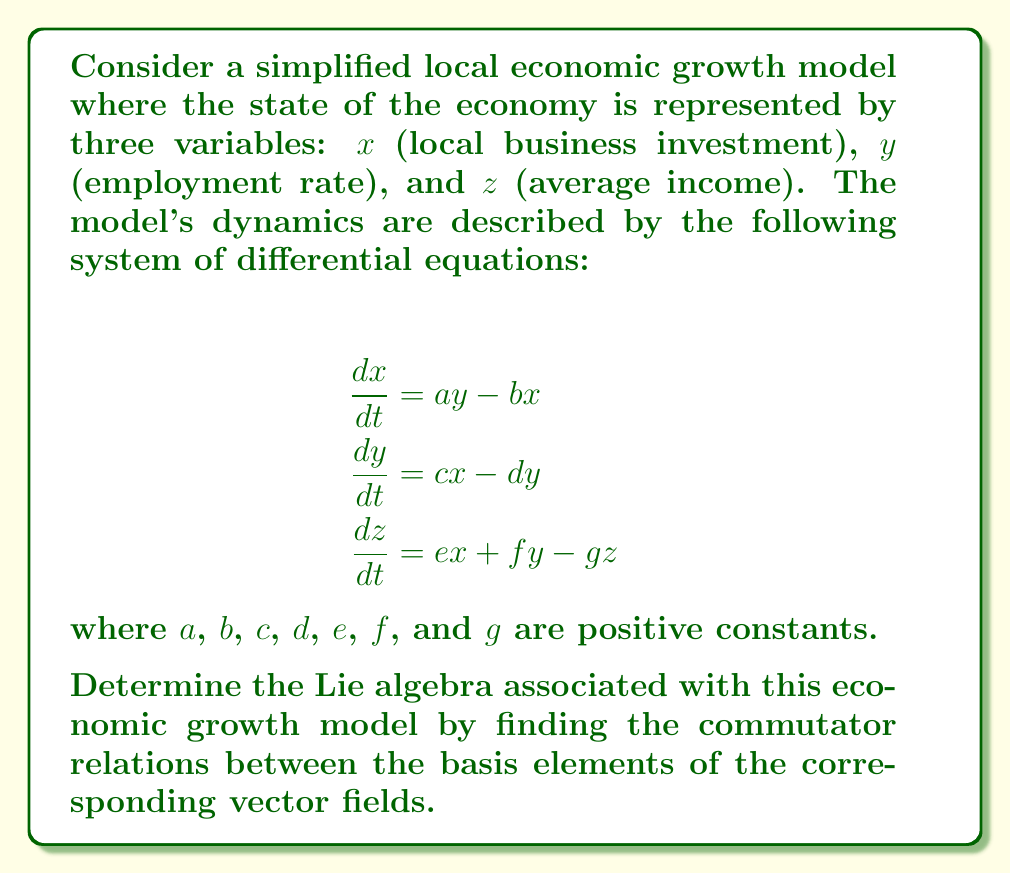Show me your answer to this math problem. To solve this problem, we'll follow these steps:

1) First, we need to identify the vector fields associated with the system. The given system of differential equations can be represented as a single vector field:

   $$V = (ay - bx)\frac{\partial}{\partial x} + (cx - dy)\frac{\partial}{\partial y} + (ex + fy - gz)\frac{\partial}{\partial z}$$

2) We can decompose this vector field into three basis elements:

   $$X_1 = y\frac{\partial}{\partial x} - x\frac{\partial}{\partial y}$$
   $$X_2 = -x\frac{\partial}{\partial x} - y\frac{\partial}{\partial y} + (ex + fy)\frac{\partial}{\partial z}$$
   $$X_3 = -z\frac{\partial}{\partial z}$$

3) The Lie algebra is determined by the commutator relations between these basis elements. The commutator of two vector fields $X$ and $Y$ is defined as:

   $$[X, Y] = XY - YX$$

4) Let's calculate the commutators:

   $[X_1, X_2]$:
   $$\begin{align*}
   [X_1, X_2] &= (y\frac{\partial}{\partial x} - x\frac{\partial}{\partial y})(-x\frac{\partial}{\partial x} - y\frac{\partial}{\partial y} + (ex + fy)\frac{\partial}{\partial z}) \\
   &- (-x\frac{\partial}{\partial x} - y\frac{\partial}{\partial y} + (ex + fy)\frac{\partial}{\partial z})(y\frac{\partial}{\partial x} - x\frac{\partial}{\partial y}) \\
   &= -ey\frac{\partial}{\partial z} + fx\frac{\partial}{\partial z} \\
   &= (fx - ey)\frac{\partial}{\partial z}
   \end{align*}$$

   $[X_1, X_3] = [X_2, X_3] = 0$ (since $X_3$ commutes with both $X_1$ and $X_2$)

5) Therefore, the non-zero commutator relation is:

   $$[X_1, X_2] = (fx - ey)\frac{\partial}{\partial z}$$

This commutator relation, along with the zero commutators involving $X_3$, defines the Lie algebra of the economic growth model.
Answer: The Lie algebra is defined by: $[X_1, X_2] = (fx - ey)\frac{\partial}{\partial z}$, $[X_1, X_3] = [X_2, X_3] = 0$ 